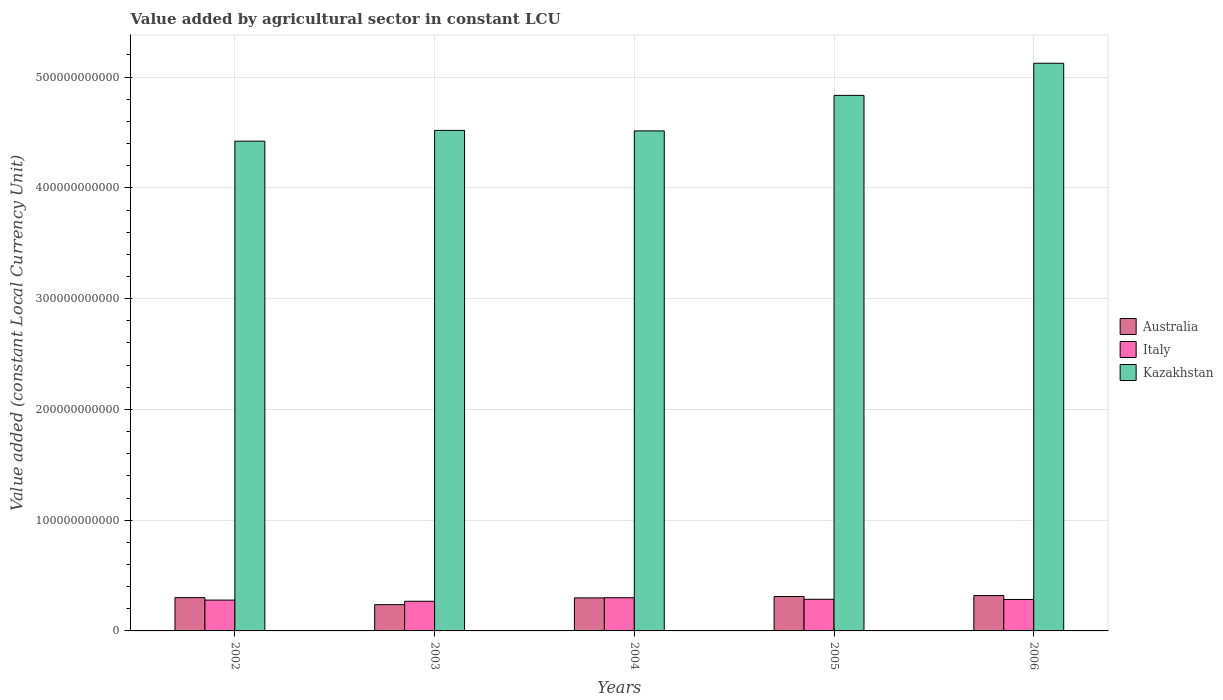How many different coloured bars are there?
Provide a succinct answer. 3. Are the number of bars per tick equal to the number of legend labels?
Make the answer very short. Yes. Are the number of bars on each tick of the X-axis equal?
Provide a short and direct response. Yes. What is the label of the 5th group of bars from the left?
Provide a short and direct response. 2006. What is the value added by agricultural sector in Kazakhstan in 2002?
Provide a succinct answer. 4.42e+11. Across all years, what is the maximum value added by agricultural sector in Kazakhstan?
Your answer should be compact. 5.12e+11. Across all years, what is the minimum value added by agricultural sector in Australia?
Keep it short and to the point. 2.37e+1. In which year was the value added by agricultural sector in Australia minimum?
Offer a very short reply. 2003. What is the total value added by agricultural sector in Australia in the graph?
Ensure brevity in your answer.  1.47e+11. What is the difference between the value added by agricultural sector in Kazakhstan in 2003 and that in 2004?
Your answer should be compact. 4.52e+08. What is the difference between the value added by agricultural sector in Australia in 2002 and the value added by agricultural sector in Kazakhstan in 2004?
Give a very brief answer. -4.21e+11. What is the average value added by agricultural sector in Australia per year?
Provide a short and direct response. 2.93e+1. In the year 2006, what is the difference between the value added by agricultural sector in Kazakhstan and value added by agricultural sector in Italy?
Give a very brief answer. 4.84e+11. What is the ratio of the value added by agricultural sector in Australia in 2003 to that in 2006?
Your response must be concise. 0.74. Is the value added by agricultural sector in Australia in 2005 less than that in 2006?
Provide a succinct answer. Yes. What is the difference between the highest and the second highest value added by agricultural sector in Australia?
Your answer should be very brief. 8.42e+08. What is the difference between the highest and the lowest value added by agricultural sector in Italy?
Provide a succinct answer. 3.21e+09. In how many years, is the value added by agricultural sector in Italy greater than the average value added by agricultural sector in Italy taken over all years?
Offer a very short reply. 3. Is the sum of the value added by agricultural sector in Australia in 2004 and 2006 greater than the maximum value added by agricultural sector in Kazakhstan across all years?
Make the answer very short. No. What does the 3rd bar from the left in 2005 represents?
Give a very brief answer. Kazakhstan. What does the 2nd bar from the right in 2006 represents?
Your answer should be very brief. Italy. Is it the case that in every year, the sum of the value added by agricultural sector in Kazakhstan and value added by agricultural sector in Italy is greater than the value added by agricultural sector in Australia?
Ensure brevity in your answer.  Yes. How many bars are there?
Make the answer very short. 15. What is the difference between two consecutive major ticks on the Y-axis?
Offer a very short reply. 1.00e+11. Does the graph contain grids?
Offer a very short reply. Yes. What is the title of the graph?
Your answer should be compact. Value added by agricultural sector in constant LCU. What is the label or title of the Y-axis?
Provide a succinct answer. Value added (constant Local Currency Unit). What is the Value added (constant Local Currency Unit) in Australia in 2002?
Give a very brief answer. 3.00e+1. What is the Value added (constant Local Currency Unit) of Italy in 2002?
Your answer should be very brief. 2.78e+1. What is the Value added (constant Local Currency Unit) in Kazakhstan in 2002?
Your response must be concise. 4.42e+11. What is the Value added (constant Local Currency Unit) in Australia in 2003?
Your answer should be very brief. 2.37e+1. What is the Value added (constant Local Currency Unit) of Italy in 2003?
Make the answer very short. 2.68e+1. What is the Value added (constant Local Currency Unit) of Kazakhstan in 2003?
Ensure brevity in your answer.  4.52e+11. What is the Value added (constant Local Currency Unit) of Australia in 2004?
Your response must be concise. 2.98e+1. What is the Value added (constant Local Currency Unit) in Italy in 2004?
Ensure brevity in your answer.  3.00e+1. What is the Value added (constant Local Currency Unit) in Kazakhstan in 2004?
Your answer should be compact. 4.51e+11. What is the Value added (constant Local Currency Unit) in Australia in 2005?
Provide a short and direct response. 3.11e+1. What is the Value added (constant Local Currency Unit) of Italy in 2005?
Offer a terse response. 2.86e+1. What is the Value added (constant Local Currency Unit) of Kazakhstan in 2005?
Provide a succinct answer. 4.83e+11. What is the Value added (constant Local Currency Unit) of Australia in 2006?
Keep it short and to the point. 3.19e+1. What is the Value added (constant Local Currency Unit) in Italy in 2006?
Offer a very short reply. 2.84e+1. What is the Value added (constant Local Currency Unit) of Kazakhstan in 2006?
Your answer should be compact. 5.12e+11. Across all years, what is the maximum Value added (constant Local Currency Unit) in Australia?
Keep it short and to the point. 3.19e+1. Across all years, what is the maximum Value added (constant Local Currency Unit) of Italy?
Offer a very short reply. 3.00e+1. Across all years, what is the maximum Value added (constant Local Currency Unit) of Kazakhstan?
Offer a very short reply. 5.12e+11. Across all years, what is the minimum Value added (constant Local Currency Unit) in Australia?
Give a very brief answer. 2.37e+1. Across all years, what is the minimum Value added (constant Local Currency Unit) of Italy?
Provide a succinct answer. 2.68e+1. Across all years, what is the minimum Value added (constant Local Currency Unit) in Kazakhstan?
Your answer should be compact. 4.42e+11. What is the total Value added (constant Local Currency Unit) in Australia in the graph?
Provide a short and direct response. 1.47e+11. What is the total Value added (constant Local Currency Unit) in Italy in the graph?
Provide a short and direct response. 1.42e+11. What is the total Value added (constant Local Currency Unit) of Kazakhstan in the graph?
Keep it short and to the point. 2.34e+12. What is the difference between the Value added (constant Local Currency Unit) in Australia in 2002 and that in 2003?
Your answer should be compact. 6.35e+09. What is the difference between the Value added (constant Local Currency Unit) in Italy in 2002 and that in 2003?
Keep it short and to the point. 1.07e+09. What is the difference between the Value added (constant Local Currency Unit) of Kazakhstan in 2002 and that in 2003?
Your answer should be compact. -9.73e+09. What is the difference between the Value added (constant Local Currency Unit) in Australia in 2002 and that in 2004?
Offer a terse response. 2.33e+08. What is the difference between the Value added (constant Local Currency Unit) of Italy in 2002 and that in 2004?
Offer a terse response. -2.13e+09. What is the difference between the Value added (constant Local Currency Unit) in Kazakhstan in 2002 and that in 2004?
Provide a short and direct response. -9.28e+09. What is the difference between the Value added (constant Local Currency Unit) of Australia in 2002 and that in 2005?
Ensure brevity in your answer.  -1.03e+09. What is the difference between the Value added (constant Local Currency Unit) in Italy in 2002 and that in 2005?
Your response must be concise. -7.35e+08. What is the difference between the Value added (constant Local Currency Unit) of Kazakhstan in 2002 and that in 2005?
Provide a short and direct response. -4.13e+1. What is the difference between the Value added (constant Local Currency Unit) in Australia in 2002 and that in 2006?
Ensure brevity in your answer.  -1.87e+09. What is the difference between the Value added (constant Local Currency Unit) in Italy in 2002 and that in 2006?
Your answer should be compact. -5.66e+08. What is the difference between the Value added (constant Local Currency Unit) in Kazakhstan in 2002 and that in 2006?
Give a very brief answer. -7.03e+1. What is the difference between the Value added (constant Local Currency Unit) of Australia in 2003 and that in 2004?
Provide a short and direct response. -6.11e+09. What is the difference between the Value added (constant Local Currency Unit) in Italy in 2003 and that in 2004?
Your answer should be very brief. -3.21e+09. What is the difference between the Value added (constant Local Currency Unit) in Kazakhstan in 2003 and that in 2004?
Give a very brief answer. 4.52e+08. What is the difference between the Value added (constant Local Currency Unit) of Australia in 2003 and that in 2005?
Your answer should be very brief. -7.38e+09. What is the difference between the Value added (constant Local Currency Unit) of Italy in 2003 and that in 2005?
Offer a terse response. -1.81e+09. What is the difference between the Value added (constant Local Currency Unit) in Kazakhstan in 2003 and that in 2005?
Ensure brevity in your answer.  -3.16e+1. What is the difference between the Value added (constant Local Currency Unit) of Australia in 2003 and that in 2006?
Offer a terse response. -8.22e+09. What is the difference between the Value added (constant Local Currency Unit) in Italy in 2003 and that in 2006?
Your response must be concise. -1.64e+09. What is the difference between the Value added (constant Local Currency Unit) in Kazakhstan in 2003 and that in 2006?
Ensure brevity in your answer.  -6.06e+1. What is the difference between the Value added (constant Local Currency Unit) in Australia in 2004 and that in 2005?
Your answer should be very brief. -1.26e+09. What is the difference between the Value added (constant Local Currency Unit) of Italy in 2004 and that in 2005?
Your answer should be compact. 1.40e+09. What is the difference between the Value added (constant Local Currency Unit) of Kazakhstan in 2004 and that in 2005?
Make the answer very short. -3.21e+1. What is the difference between the Value added (constant Local Currency Unit) of Australia in 2004 and that in 2006?
Offer a terse response. -2.11e+09. What is the difference between the Value added (constant Local Currency Unit) in Italy in 2004 and that in 2006?
Make the answer very short. 1.57e+09. What is the difference between the Value added (constant Local Currency Unit) of Kazakhstan in 2004 and that in 2006?
Give a very brief answer. -6.11e+1. What is the difference between the Value added (constant Local Currency Unit) in Australia in 2005 and that in 2006?
Make the answer very short. -8.42e+08. What is the difference between the Value added (constant Local Currency Unit) in Italy in 2005 and that in 2006?
Keep it short and to the point. 1.69e+08. What is the difference between the Value added (constant Local Currency Unit) of Kazakhstan in 2005 and that in 2006?
Your response must be concise. -2.90e+1. What is the difference between the Value added (constant Local Currency Unit) in Australia in 2002 and the Value added (constant Local Currency Unit) in Italy in 2003?
Your answer should be compact. 3.28e+09. What is the difference between the Value added (constant Local Currency Unit) of Australia in 2002 and the Value added (constant Local Currency Unit) of Kazakhstan in 2003?
Provide a short and direct response. -4.22e+11. What is the difference between the Value added (constant Local Currency Unit) in Italy in 2002 and the Value added (constant Local Currency Unit) in Kazakhstan in 2003?
Your response must be concise. -4.24e+11. What is the difference between the Value added (constant Local Currency Unit) of Australia in 2002 and the Value added (constant Local Currency Unit) of Italy in 2004?
Provide a succinct answer. 7.44e+07. What is the difference between the Value added (constant Local Currency Unit) in Australia in 2002 and the Value added (constant Local Currency Unit) in Kazakhstan in 2004?
Make the answer very short. -4.21e+11. What is the difference between the Value added (constant Local Currency Unit) of Italy in 2002 and the Value added (constant Local Currency Unit) of Kazakhstan in 2004?
Your response must be concise. -4.24e+11. What is the difference between the Value added (constant Local Currency Unit) in Australia in 2002 and the Value added (constant Local Currency Unit) in Italy in 2005?
Make the answer very short. 1.47e+09. What is the difference between the Value added (constant Local Currency Unit) of Australia in 2002 and the Value added (constant Local Currency Unit) of Kazakhstan in 2005?
Your answer should be compact. -4.53e+11. What is the difference between the Value added (constant Local Currency Unit) of Italy in 2002 and the Value added (constant Local Currency Unit) of Kazakhstan in 2005?
Your answer should be very brief. -4.56e+11. What is the difference between the Value added (constant Local Currency Unit) in Australia in 2002 and the Value added (constant Local Currency Unit) in Italy in 2006?
Your response must be concise. 1.64e+09. What is the difference between the Value added (constant Local Currency Unit) of Australia in 2002 and the Value added (constant Local Currency Unit) of Kazakhstan in 2006?
Your response must be concise. -4.82e+11. What is the difference between the Value added (constant Local Currency Unit) of Italy in 2002 and the Value added (constant Local Currency Unit) of Kazakhstan in 2006?
Provide a short and direct response. -4.85e+11. What is the difference between the Value added (constant Local Currency Unit) in Australia in 2003 and the Value added (constant Local Currency Unit) in Italy in 2004?
Offer a terse response. -6.27e+09. What is the difference between the Value added (constant Local Currency Unit) of Australia in 2003 and the Value added (constant Local Currency Unit) of Kazakhstan in 2004?
Provide a succinct answer. -4.28e+11. What is the difference between the Value added (constant Local Currency Unit) in Italy in 2003 and the Value added (constant Local Currency Unit) in Kazakhstan in 2004?
Ensure brevity in your answer.  -4.25e+11. What is the difference between the Value added (constant Local Currency Unit) of Australia in 2003 and the Value added (constant Local Currency Unit) of Italy in 2005?
Give a very brief answer. -4.87e+09. What is the difference between the Value added (constant Local Currency Unit) of Australia in 2003 and the Value added (constant Local Currency Unit) of Kazakhstan in 2005?
Offer a very short reply. -4.60e+11. What is the difference between the Value added (constant Local Currency Unit) of Italy in 2003 and the Value added (constant Local Currency Unit) of Kazakhstan in 2005?
Provide a short and direct response. -4.57e+11. What is the difference between the Value added (constant Local Currency Unit) in Australia in 2003 and the Value added (constant Local Currency Unit) in Italy in 2006?
Make the answer very short. -4.70e+09. What is the difference between the Value added (constant Local Currency Unit) of Australia in 2003 and the Value added (constant Local Currency Unit) of Kazakhstan in 2006?
Provide a succinct answer. -4.89e+11. What is the difference between the Value added (constant Local Currency Unit) of Italy in 2003 and the Value added (constant Local Currency Unit) of Kazakhstan in 2006?
Provide a short and direct response. -4.86e+11. What is the difference between the Value added (constant Local Currency Unit) of Australia in 2004 and the Value added (constant Local Currency Unit) of Italy in 2005?
Your answer should be very brief. 1.24e+09. What is the difference between the Value added (constant Local Currency Unit) in Australia in 2004 and the Value added (constant Local Currency Unit) in Kazakhstan in 2005?
Give a very brief answer. -4.54e+11. What is the difference between the Value added (constant Local Currency Unit) in Italy in 2004 and the Value added (constant Local Currency Unit) in Kazakhstan in 2005?
Make the answer very short. -4.54e+11. What is the difference between the Value added (constant Local Currency Unit) of Australia in 2004 and the Value added (constant Local Currency Unit) of Italy in 2006?
Provide a succinct answer. 1.41e+09. What is the difference between the Value added (constant Local Currency Unit) in Australia in 2004 and the Value added (constant Local Currency Unit) in Kazakhstan in 2006?
Keep it short and to the point. -4.83e+11. What is the difference between the Value added (constant Local Currency Unit) in Italy in 2004 and the Value added (constant Local Currency Unit) in Kazakhstan in 2006?
Your answer should be very brief. -4.83e+11. What is the difference between the Value added (constant Local Currency Unit) of Australia in 2005 and the Value added (constant Local Currency Unit) of Italy in 2006?
Your answer should be compact. 2.67e+09. What is the difference between the Value added (constant Local Currency Unit) in Australia in 2005 and the Value added (constant Local Currency Unit) in Kazakhstan in 2006?
Your answer should be very brief. -4.81e+11. What is the difference between the Value added (constant Local Currency Unit) in Italy in 2005 and the Value added (constant Local Currency Unit) in Kazakhstan in 2006?
Your response must be concise. -4.84e+11. What is the average Value added (constant Local Currency Unit) in Australia per year?
Ensure brevity in your answer.  2.93e+1. What is the average Value added (constant Local Currency Unit) in Italy per year?
Keep it short and to the point. 2.83e+1. What is the average Value added (constant Local Currency Unit) of Kazakhstan per year?
Your response must be concise. 4.68e+11. In the year 2002, what is the difference between the Value added (constant Local Currency Unit) in Australia and Value added (constant Local Currency Unit) in Italy?
Provide a short and direct response. 2.21e+09. In the year 2002, what is the difference between the Value added (constant Local Currency Unit) of Australia and Value added (constant Local Currency Unit) of Kazakhstan?
Provide a succinct answer. -4.12e+11. In the year 2002, what is the difference between the Value added (constant Local Currency Unit) in Italy and Value added (constant Local Currency Unit) in Kazakhstan?
Give a very brief answer. -4.14e+11. In the year 2003, what is the difference between the Value added (constant Local Currency Unit) of Australia and Value added (constant Local Currency Unit) of Italy?
Offer a very short reply. -3.07e+09. In the year 2003, what is the difference between the Value added (constant Local Currency Unit) in Australia and Value added (constant Local Currency Unit) in Kazakhstan?
Your answer should be very brief. -4.28e+11. In the year 2003, what is the difference between the Value added (constant Local Currency Unit) of Italy and Value added (constant Local Currency Unit) of Kazakhstan?
Your response must be concise. -4.25e+11. In the year 2004, what is the difference between the Value added (constant Local Currency Unit) of Australia and Value added (constant Local Currency Unit) of Italy?
Your answer should be compact. -1.59e+08. In the year 2004, what is the difference between the Value added (constant Local Currency Unit) in Australia and Value added (constant Local Currency Unit) in Kazakhstan?
Provide a succinct answer. -4.22e+11. In the year 2004, what is the difference between the Value added (constant Local Currency Unit) of Italy and Value added (constant Local Currency Unit) of Kazakhstan?
Ensure brevity in your answer.  -4.21e+11. In the year 2005, what is the difference between the Value added (constant Local Currency Unit) of Australia and Value added (constant Local Currency Unit) of Italy?
Keep it short and to the point. 2.51e+09. In the year 2005, what is the difference between the Value added (constant Local Currency Unit) in Australia and Value added (constant Local Currency Unit) in Kazakhstan?
Your answer should be compact. -4.52e+11. In the year 2005, what is the difference between the Value added (constant Local Currency Unit) in Italy and Value added (constant Local Currency Unit) in Kazakhstan?
Your answer should be compact. -4.55e+11. In the year 2006, what is the difference between the Value added (constant Local Currency Unit) in Australia and Value added (constant Local Currency Unit) in Italy?
Ensure brevity in your answer.  3.52e+09. In the year 2006, what is the difference between the Value added (constant Local Currency Unit) of Australia and Value added (constant Local Currency Unit) of Kazakhstan?
Ensure brevity in your answer.  -4.81e+11. In the year 2006, what is the difference between the Value added (constant Local Currency Unit) of Italy and Value added (constant Local Currency Unit) of Kazakhstan?
Offer a very short reply. -4.84e+11. What is the ratio of the Value added (constant Local Currency Unit) in Australia in 2002 to that in 2003?
Keep it short and to the point. 1.27. What is the ratio of the Value added (constant Local Currency Unit) in Kazakhstan in 2002 to that in 2003?
Your answer should be very brief. 0.98. What is the ratio of the Value added (constant Local Currency Unit) of Australia in 2002 to that in 2004?
Make the answer very short. 1.01. What is the ratio of the Value added (constant Local Currency Unit) of Italy in 2002 to that in 2004?
Your answer should be very brief. 0.93. What is the ratio of the Value added (constant Local Currency Unit) in Kazakhstan in 2002 to that in 2004?
Offer a very short reply. 0.98. What is the ratio of the Value added (constant Local Currency Unit) in Australia in 2002 to that in 2005?
Your response must be concise. 0.97. What is the ratio of the Value added (constant Local Currency Unit) in Italy in 2002 to that in 2005?
Give a very brief answer. 0.97. What is the ratio of the Value added (constant Local Currency Unit) in Kazakhstan in 2002 to that in 2005?
Your answer should be compact. 0.91. What is the ratio of the Value added (constant Local Currency Unit) of Australia in 2002 to that in 2006?
Provide a succinct answer. 0.94. What is the ratio of the Value added (constant Local Currency Unit) of Italy in 2002 to that in 2006?
Offer a terse response. 0.98. What is the ratio of the Value added (constant Local Currency Unit) in Kazakhstan in 2002 to that in 2006?
Provide a succinct answer. 0.86. What is the ratio of the Value added (constant Local Currency Unit) of Australia in 2003 to that in 2004?
Give a very brief answer. 0.79. What is the ratio of the Value added (constant Local Currency Unit) in Italy in 2003 to that in 2004?
Offer a terse response. 0.89. What is the ratio of the Value added (constant Local Currency Unit) in Kazakhstan in 2003 to that in 2004?
Keep it short and to the point. 1. What is the ratio of the Value added (constant Local Currency Unit) of Australia in 2003 to that in 2005?
Offer a very short reply. 0.76. What is the ratio of the Value added (constant Local Currency Unit) in Italy in 2003 to that in 2005?
Make the answer very short. 0.94. What is the ratio of the Value added (constant Local Currency Unit) in Kazakhstan in 2003 to that in 2005?
Ensure brevity in your answer.  0.93. What is the ratio of the Value added (constant Local Currency Unit) of Australia in 2003 to that in 2006?
Make the answer very short. 0.74. What is the ratio of the Value added (constant Local Currency Unit) in Italy in 2003 to that in 2006?
Ensure brevity in your answer.  0.94. What is the ratio of the Value added (constant Local Currency Unit) of Kazakhstan in 2003 to that in 2006?
Make the answer very short. 0.88. What is the ratio of the Value added (constant Local Currency Unit) of Australia in 2004 to that in 2005?
Your answer should be very brief. 0.96. What is the ratio of the Value added (constant Local Currency Unit) of Italy in 2004 to that in 2005?
Your answer should be compact. 1.05. What is the ratio of the Value added (constant Local Currency Unit) in Kazakhstan in 2004 to that in 2005?
Your answer should be compact. 0.93. What is the ratio of the Value added (constant Local Currency Unit) in Australia in 2004 to that in 2006?
Offer a terse response. 0.93. What is the ratio of the Value added (constant Local Currency Unit) in Italy in 2004 to that in 2006?
Give a very brief answer. 1.06. What is the ratio of the Value added (constant Local Currency Unit) of Kazakhstan in 2004 to that in 2006?
Make the answer very short. 0.88. What is the ratio of the Value added (constant Local Currency Unit) of Australia in 2005 to that in 2006?
Provide a short and direct response. 0.97. What is the ratio of the Value added (constant Local Currency Unit) in Italy in 2005 to that in 2006?
Ensure brevity in your answer.  1.01. What is the ratio of the Value added (constant Local Currency Unit) of Kazakhstan in 2005 to that in 2006?
Your answer should be compact. 0.94. What is the difference between the highest and the second highest Value added (constant Local Currency Unit) in Australia?
Provide a succinct answer. 8.42e+08. What is the difference between the highest and the second highest Value added (constant Local Currency Unit) in Italy?
Give a very brief answer. 1.40e+09. What is the difference between the highest and the second highest Value added (constant Local Currency Unit) in Kazakhstan?
Make the answer very short. 2.90e+1. What is the difference between the highest and the lowest Value added (constant Local Currency Unit) in Australia?
Give a very brief answer. 8.22e+09. What is the difference between the highest and the lowest Value added (constant Local Currency Unit) in Italy?
Your response must be concise. 3.21e+09. What is the difference between the highest and the lowest Value added (constant Local Currency Unit) in Kazakhstan?
Your answer should be very brief. 7.03e+1. 